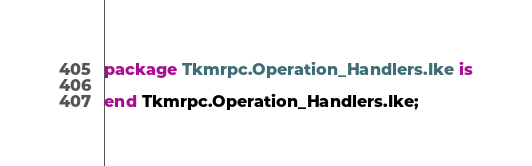Convert code to text. <code><loc_0><loc_0><loc_500><loc_500><_Ada_>package Tkmrpc.Operation_Handlers.Ike is

end Tkmrpc.Operation_Handlers.Ike;
</code> 